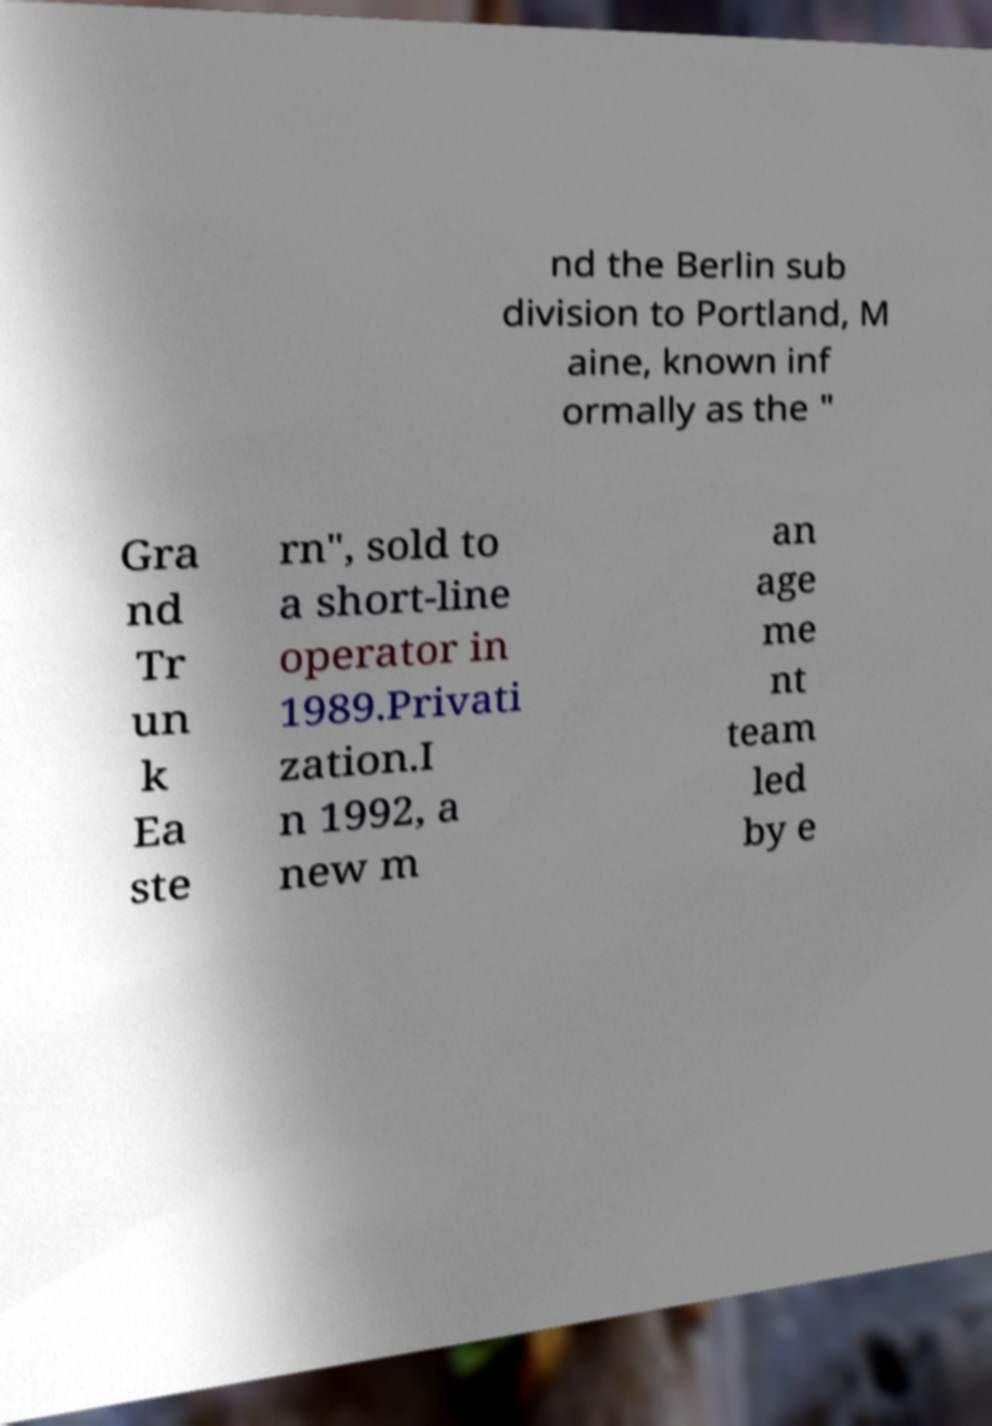For documentation purposes, I need the text within this image transcribed. Could you provide that? nd the Berlin sub division to Portland, M aine, known inf ormally as the " Gra nd Tr un k Ea ste rn", sold to a short-line operator in 1989.Privati zation.I n 1992, a new m an age me nt team led by e 